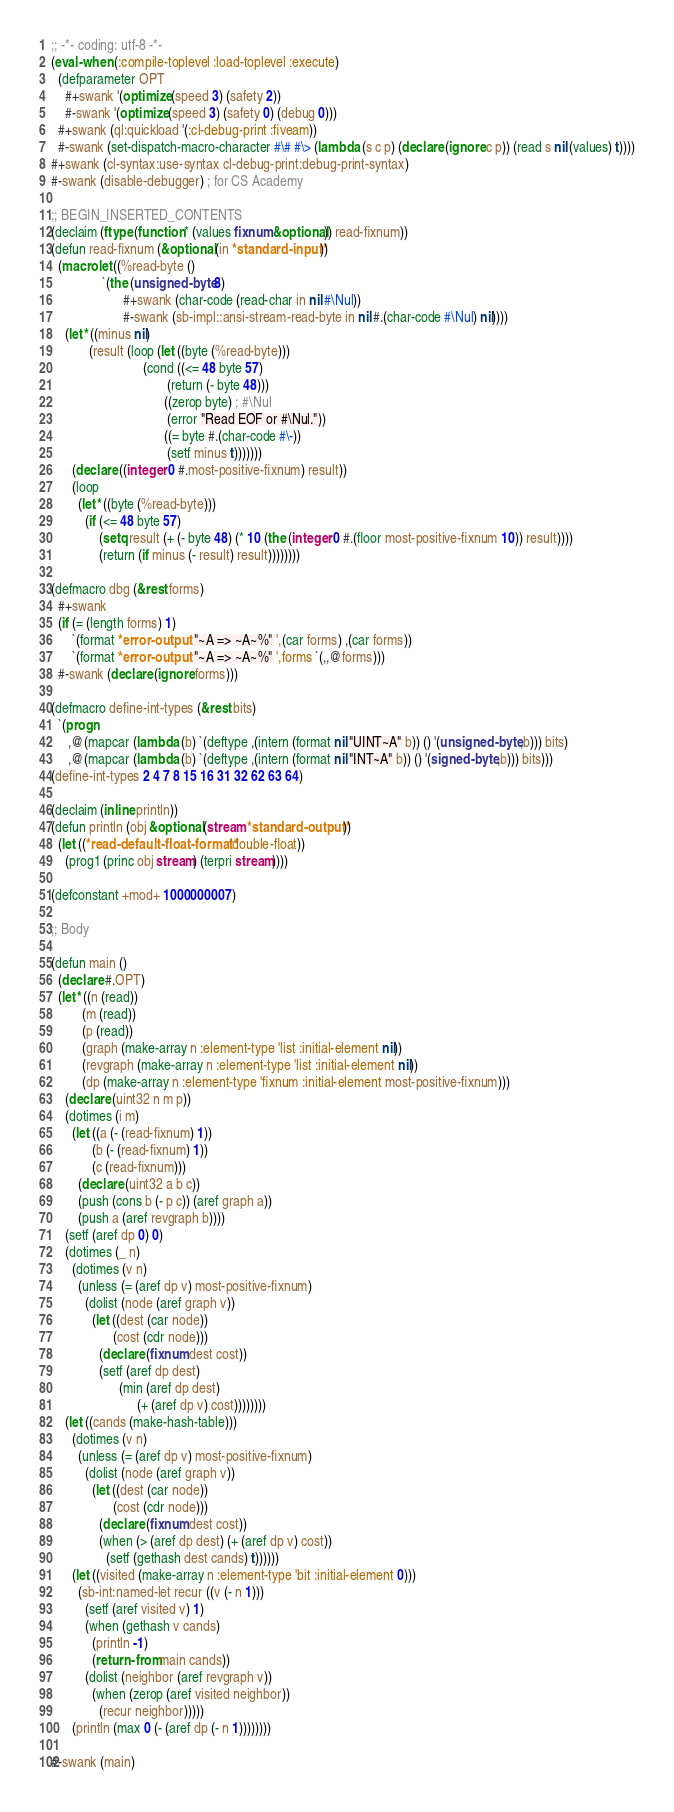<code> <loc_0><loc_0><loc_500><loc_500><_Lisp_>;; -*- coding: utf-8 -*-
(eval-when (:compile-toplevel :load-toplevel :execute)
  (defparameter OPT
    #+swank '(optimize (speed 3) (safety 2))
    #-swank '(optimize (speed 3) (safety 0) (debug 0)))
  #+swank (ql:quickload '(:cl-debug-print :fiveam))
  #-swank (set-dispatch-macro-character #\# #\> (lambda (s c p) (declare (ignore c p)) (read s nil (values) t))))
#+swank (cl-syntax:use-syntax cl-debug-print:debug-print-syntax)
#-swank (disable-debugger) ; for CS Academy

;; BEGIN_INSERTED_CONTENTS
(declaim (ftype (function * (values fixnum &optional)) read-fixnum))
(defun read-fixnum (&optional (in *standard-input*))
  (macrolet ((%read-byte ()
               `(the (unsigned-byte 8)
                     #+swank (char-code (read-char in nil #\Nul))
                     #-swank (sb-impl::ansi-stream-read-byte in nil #.(char-code #\Nul) nil))))
    (let* ((minus nil)
           (result (loop (let ((byte (%read-byte)))
                           (cond ((<= 48 byte 57)
                                  (return (- byte 48)))
                                 ((zerop byte) ; #\Nul
                                  (error "Read EOF or #\Nul."))
                                 ((= byte #.(char-code #\-))
                                  (setf minus t)))))))
      (declare ((integer 0 #.most-positive-fixnum) result))
      (loop
        (let* ((byte (%read-byte)))
          (if (<= 48 byte 57)
              (setq result (+ (- byte 48) (* 10 (the (integer 0 #.(floor most-positive-fixnum 10)) result))))
              (return (if minus (- result) result))))))))

(defmacro dbg (&rest forms)
  #+swank
  (if (= (length forms) 1)
      `(format *error-output* "~A => ~A~%" ',(car forms) ,(car forms))
      `(format *error-output* "~A => ~A~%" ',forms `(,,@forms)))
  #-swank (declare (ignore forms)))

(defmacro define-int-types (&rest bits)
  `(progn
     ,@(mapcar (lambda (b) `(deftype ,(intern (format nil "UINT~A" b)) () '(unsigned-byte ,b))) bits)
     ,@(mapcar (lambda (b) `(deftype ,(intern (format nil "INT~A" b)) () '(signed-byte ,b))) bits)))
(define-int-types 2 4 7 8 15 16 31 32 62 63 64)

(declaim (inline println))
(defun println (obj &optional (stream *standard-output*))
  (let ((*read-default-float-format* 'double-float))
    (prog1 (princ obj stream) (terpri stream))))

(defconstant +mod+ 1000000007)

;; Body

(defun main ()
  (declare #.OPT)
  (let* ((n (read))
         (m (read))
         (p (read))
         (graph (make-array n :element-type 'list :initial-element nil))
         (revgraph (make-array n :element-type 'list :initial-element nil))
         (dp (make-array n :element-type 'fixnum :initial-element most-positive-fixnum)))
    (declare (uint32 n m p))
    (dotimes (i m)
      (let ((a (- (read-fixnum) 1))
            (b (- (read-fixnum) 1))
            (c (read-fixnum)))
        (declare (uint32 a b c))
        (push (cons b (- p c)) (aref graph a))
        (push a (aref revgraph b))))
    (setf (aref dp 0) 0)
    (dotimes (_ n)
      (dotimes (v n)
        (unless (= (aref dp v) most-positive-fixnum)
          (dolist (node (aref graph v))
            (let ((dest (car node))
                  (cost (cdr node)))
              (declare (fixnum dest cost))
              (setf (aref dp dest)
                    (min (aref dp dest)
                         (+ (aref dp v) cost))))))))
    (let ((cands (make-hash-table)))
      (dotimes (v n)
        (unless (= (aref dp v) most-positive-fixnum)
          (dolist (node (aref graph v))
            (let ((dest (car node))
                  (cost (cdr node)))
              (declare (fixnum dest cost))
              (when (> (aref dp dest) (+ (aref dp v) cost))
                (setf (gethash dest cands) t))))))
      (let ((visited (make-array n :element-type 'bit :initial-element 0)))
        (sb-int:named-let recur ((v (- n 1)))
          (setf (aref visited v) 1)
          (when (gethash v cands)
            (println -1)
            (return-from main cands))
          (dolist (neighbor (aref revgraph v))
            (when (zerop (aref visited neighbor))
              (recur neighbor)))))
      (println (max 0 (- (aref dp (- n 1))))))))

#-swank (main)
</code> 